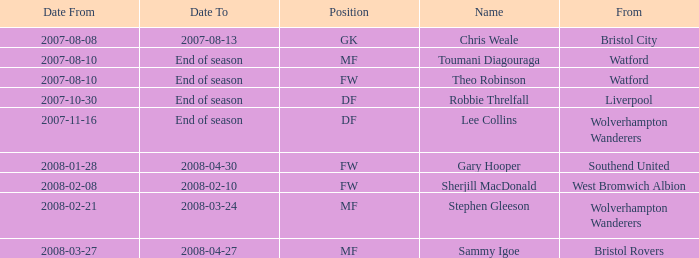Which country did the df player, who began on 30th october 2007, come from? Liverpool. 